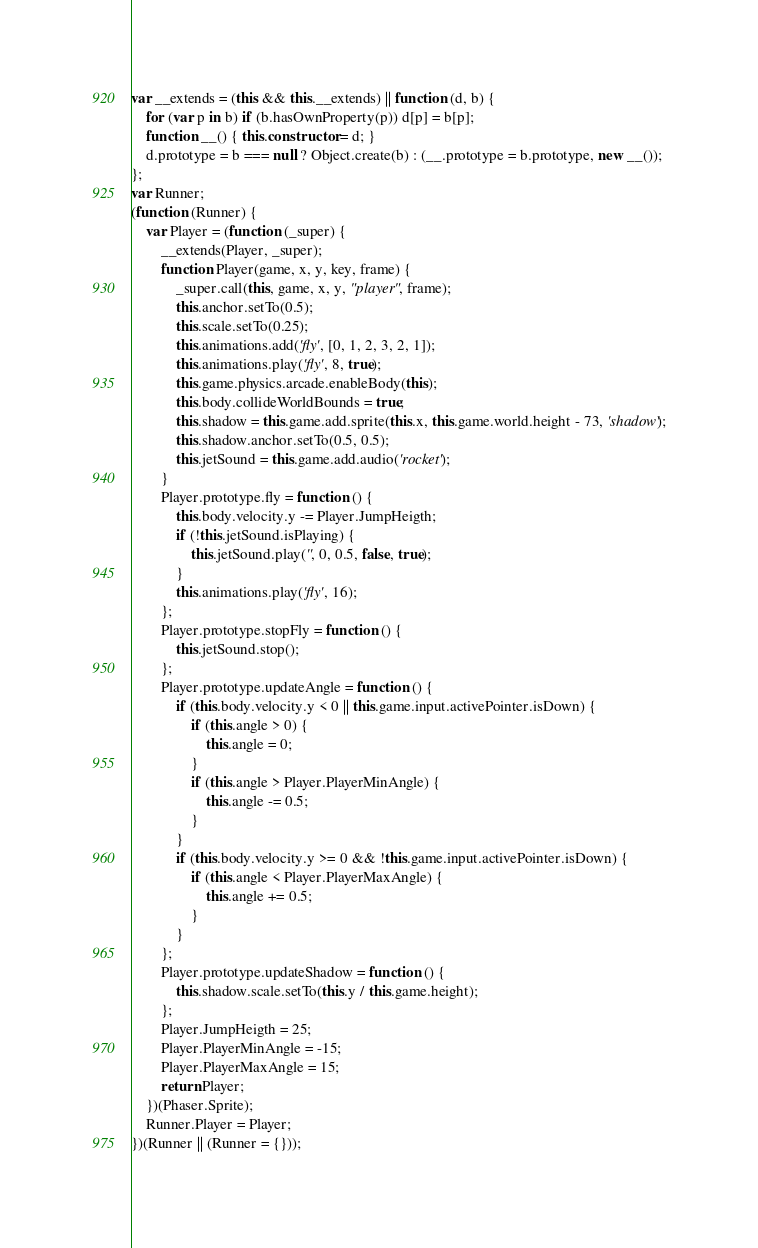Convert code to text. <code><loc_0><loc_0><loc_500><loc_500><_JavaScript_>var __extends = (this && this.__extends) || function (d, b) {
    for (var p in b) if (b.hasOwnProperty(p)) d[p] = b[p];
    function __() { this.constructor = d; }
    d.prototype = b === null ? Object.create(b) : (__.prototype = b.prototype, new __());
};
var Runner;
(function (Runner) {
    var Player = (function (_super) {
        __extends(Player, _super);
        function Player(game, x, y, key, frame) {
            _super.call(this, game, x, y, "player", frame);
            this.anchor.setTo(0.5);
            this.scale.setTo(0.25);
            this.animations.add('fly', [0, 1, 2, 3, 2, 1]);
            this.animations.play('fly', 8, true);
            this.game.physics.arcade.enableBody(this);
            this.body.collideWorldBounds = true;
            this.shadow = this.game.add.sprite(this.x, this.game.world.height - 73, 'shadow');
            this.shadow.anchor.setTo(0.5, 0.5);
            this.jetSound = this.game.add.audio('rocket');
        }
        Player.prototype.fly = function () {
            this.body.velocity.y -= Player.JumpHeigth;
            if (!this.jetSound.isPlaying) {
                this.jetSound.play('', 0, 0.5, false, true);
            }
            this.animations.play('fly', 16);
        };
        Player.prototype.stopFly = function () {
            this.jetSound.stop();
        };
        Player.prototype.updateAngle = function () {
            if (this.body.velocity.y < 0 || this.game.input.activePointer.isDown) {
                if (this.angle > 0) {
                    this.angle = 0;
                }
                if (this.angle > Player.PlayerMinAngle) {
                    this.angle -= 0.5;
                }
            }
            if (this.body.velocity.y >= 0 && !this.game.input.activePointer.isDown) {
                if (this.angle < Player.PlayerMaxAngle) {
                    this.angle += 0.5;
                }
            }
        };
        Player.prototype.updateShadow = function () {
            this.shadow.scale.setTo(this.y / this.game.height);
        };
        Player.JumpHeigth = 25;
        Player.PlayerMinAngle = -15;
        Player.PlayerMaxAngle = 15;
        return Player;
    })(Phaser.Sprite);
    Runner.Player = Player;
})(Runner || (Runner = {}));
</code> 